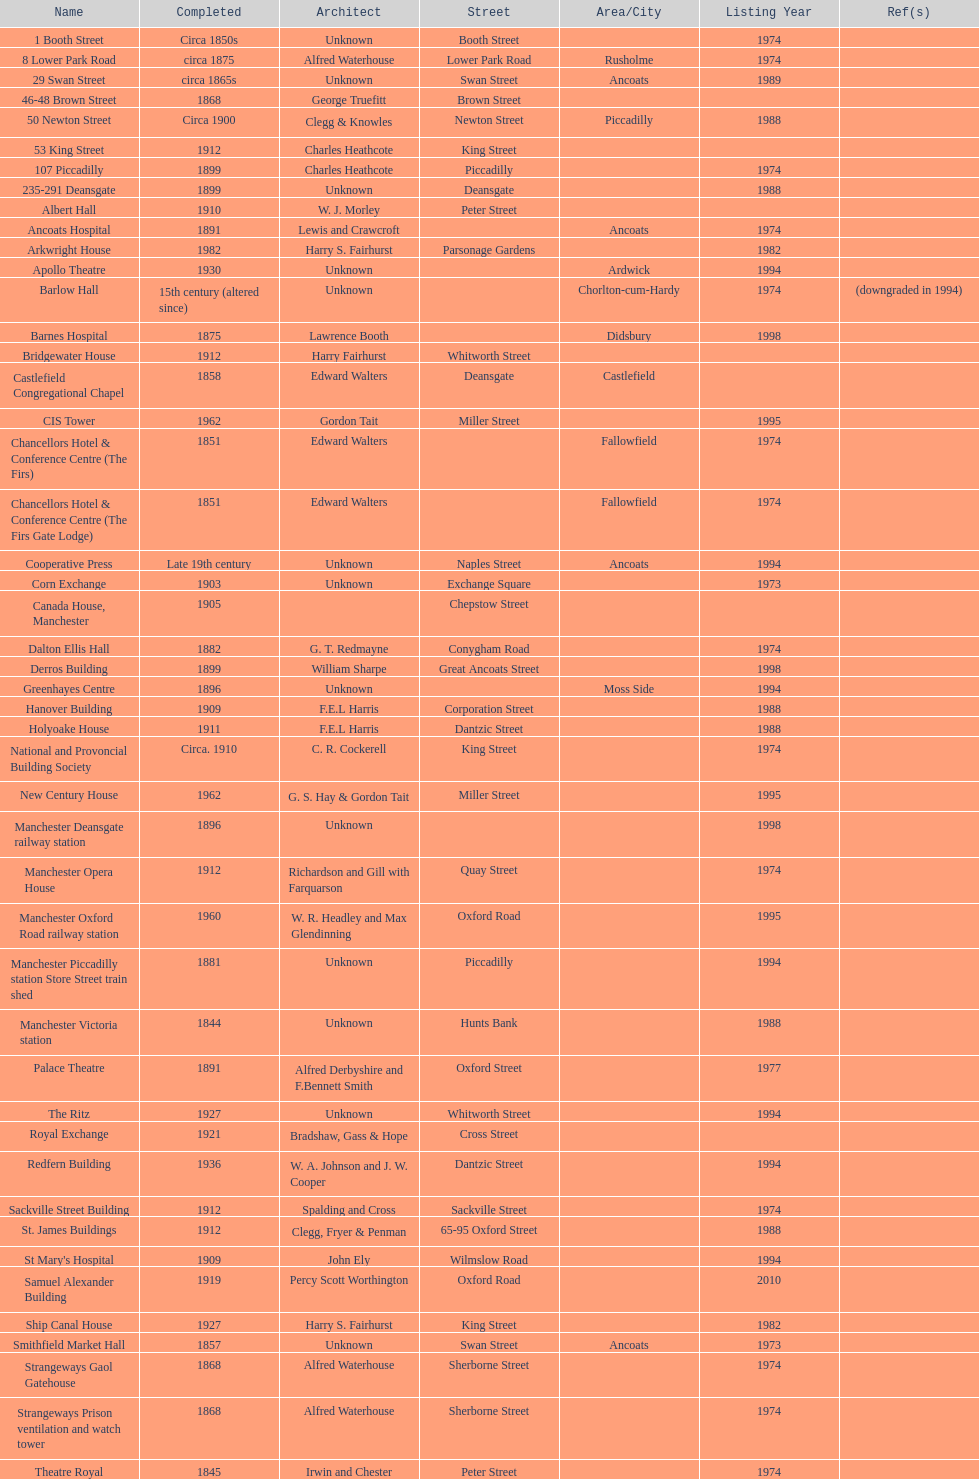Parse the table in full. {'header': ['Name', 'Completed', 'Architect', 'Street', 'Area/City', 'Listing Year', 'Ref(s)'], 'rows': [['1 Booth Street', 'Circa 1850s', 'Unknown', 'Booth Street', '', '1974', ''], ['8 Lower Park Road', 'circa 1875', 'Alfred Waterhouse', 'Lower Park Road', 'Rusholme', '1974', ''], ['29 Swan Street', 'circa 1865s', 'Unknown', 'Swan Street', 'Ancoats', '1989', ''], ['46-48 Brown Street', '1868', 'George Truefitt', 'Brown Street', '', '', ''], ['50 Newton Street', 'Circa 1900', 'Clegg & Knowles', 'Newton Street', 'Piccadilly', '1988', ''], ['53 King Street', '1912', 'Charles Heathcote', 'King Street', '', '', ''], ['107 Piccadilly', '1899', 'Charles Heathcote', 'Piccadilly', '', '1974', ''], ['235-291 Deansgate', '1899', 'Unknown', 'Deansgate', '', '1988', ''], ['Albert Hall', '1910', 'W. J. Morley', 'Peter Street', '', '', ''], ['Ancoats Hospital', '1891', 'Lewis and Crawcroft', '', 'Ancoats', '1974', ''], ['Arkwright House', '1982', 'Harry S. Fairhurst', 'Parsonage Gardens', '', '1982', ''], ['Apollo Theatre', '1930', 'Unknown', '', 'Ardwick', '1994', ''], ['Barlow Hall', '15th century (altered since)', 'Unknown', '', 'Chorlton-cum-Hardy', '1974', '(downgraded in 1994)'], ['Barnes Hospital', '1875', 'Lawrence Booth', '', 'Didsbury', '1998', ''], ['Bridgewater House', '1912', 'Harry Fairhurst', 'Whitworth Street', '', '', ''], ['Castlefield Congregational Chapel', '1858', 'Edward Walters', 'Deansgate', 'Castlefield', '', ''], ['CIS Tower', '1962', 'Gordon Tait', 'Miller Street', '', '1995', ''], ['Chancellors Hotel & Conference Centre (The Firs)', '1851', 'Edward Walters', '', 'Fallowfield', '1974', ''], ['Chancellors Hotel & Conference Centre (The Firs Gate Lodge)', '1851', 'Edward Walters', '', 'Fallowfield', '1974', ''], ['Cooperative Press', 'Late 19th century', 'Unknown', 'Naples Street', 'Ancoats', '1994', ''], ['Corn Exchange', '1903', 'Unknown', 'Exchange Square', '', '1973', ''], ['Canada House, Manchester', '1905', '', 'Chepstow Street', '', '', ''], ['Dalton Ellis Hall', '1882', 'G. T. Redmayne', 'Conygham Road', '', '1974', ''], ['Derros Building', '1899', 'William Sharpe', 'Great Ancoats Street', '', '1998', ''], ['Greenhayes Centre', '1896', 'Unknown', '', 'Moss Side', '1994', ''], ['Hanover Building', '1909', 'F.E.L Harris', 'Corporation Street', '', '1988', ''], ['Holyoake House', '1911', 'F.E.L Harris', 'Dantzic Street', '', '1988', ''], ['National and Provoncial Building Society', 'Circa. 1910', 'C. R. Cockerell', 'King Street', '', '1974', ''], ['New Century House', '1962', 'G. S. Hay & Gordon Tait', 'Miller Street', '', '1995', ''], ['Manchester Deansgate railway station', '1896', 'Unknown', '', '', '1998', ''], ['Manchester Opera House', '1912', 'Richardson and Gill with Farquarson', 'Quay Street', '', '1974', ''], ['Manchester Oxford Road railway station', '1960', 'W. R. Headley and Max Glendinning', 'Oxford Road', '', '1995', ''], ['Manchester Piccadilly station Store Street train shed', '1881', 'Unknown', 'Piccadilly', '', '1994', ''], ['Manchester Victoria station', '1844', 'Unknown', 'Hunts Bank', '', '1988', ''], ['Palace Theatre', '1891', 'Alfred Derbyshire and F.Bennett Smith', 'Oxford Street', '', '1977', ''], ['The Ritz', '1927', 'Unknown', 'Whitworth Street', '', '1994', ''], ['Royal Exchange', '1921', 'Bradshaw, Gass & Hope', 'Cross Street', '', '', ''], ['Redfern Building', '1936', 'W. A. Johnson and J. W. Cooper', 'Dantzic Street', '', '1994', ''], ['Sackville Street Building', '1912', 'Spalding and Cross', 'Sackville Street', '', '1974', ''], ['St. James Buildings', '1912', 'Clegg, Fryer & Penman', '65-95 Oxford Street', '', '1988', ''], ["St Mary's Hospital", '1909', 'John Ely', 'Wilmslow Road', '', '1994', ''], ['Samuel Alexander Building', '1919', 'Percy Scott Worthington', 'Oxford Road', '', '2010', ''], ['Ship Canal House', '1927', 'Harry S. Fairhurst', 'King Street', '', '1982', ''], ['Smithfield Market Hall', '1857', 'Unknown', 'Swan Street', 'Ancoats', '1973', ''], ['Strangeways Gaol Gatehouse', '1868', 'Alfred Waterhouse', 'Sherborne Street', '', '1974', ''], ['Strangeways Prison ventilation and watch tower', '1868', 'Alfred Waterhouse', 'Sherborne Street', '', '1974', ''], ['Theatre Royal', '1845', 'Irwin and Chester', 'Peter Street', '', '1974', ''], ['Toast Rack', '1960', 'L. C. Howitt', '', 'Fallowfield', '1999', ''], ['The Old Wellington Inn', 'Mid-16th century', 'Unknown', 'Shambles Square', '', '1952', ''], ['Whitworth Park Mansions', 'Circa 1840s', 'Unknown', '', 'Whitworth Park', '1974', '']]} How many names are listed with an image? 39. 